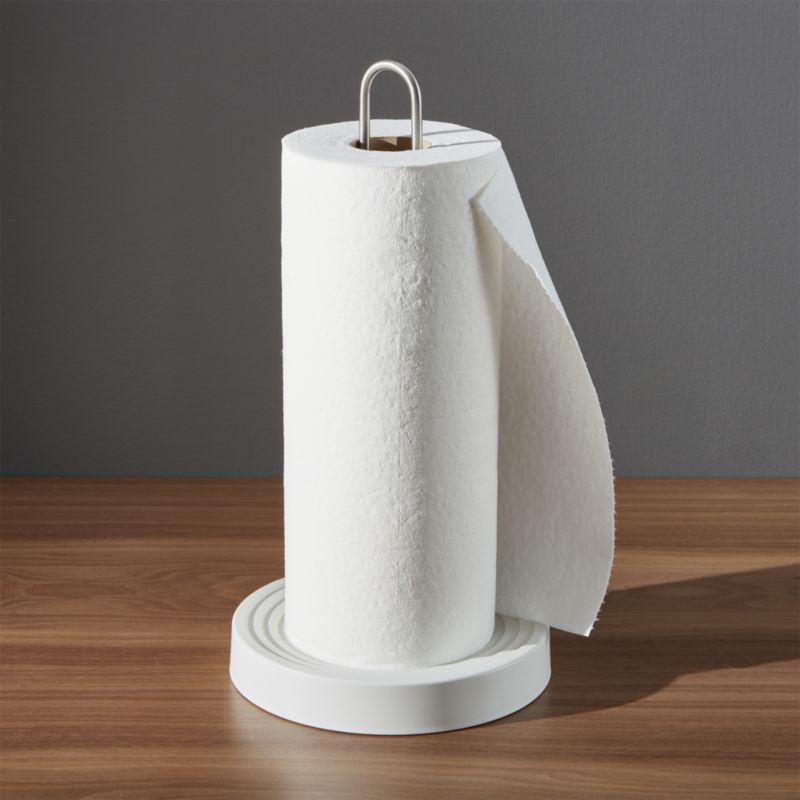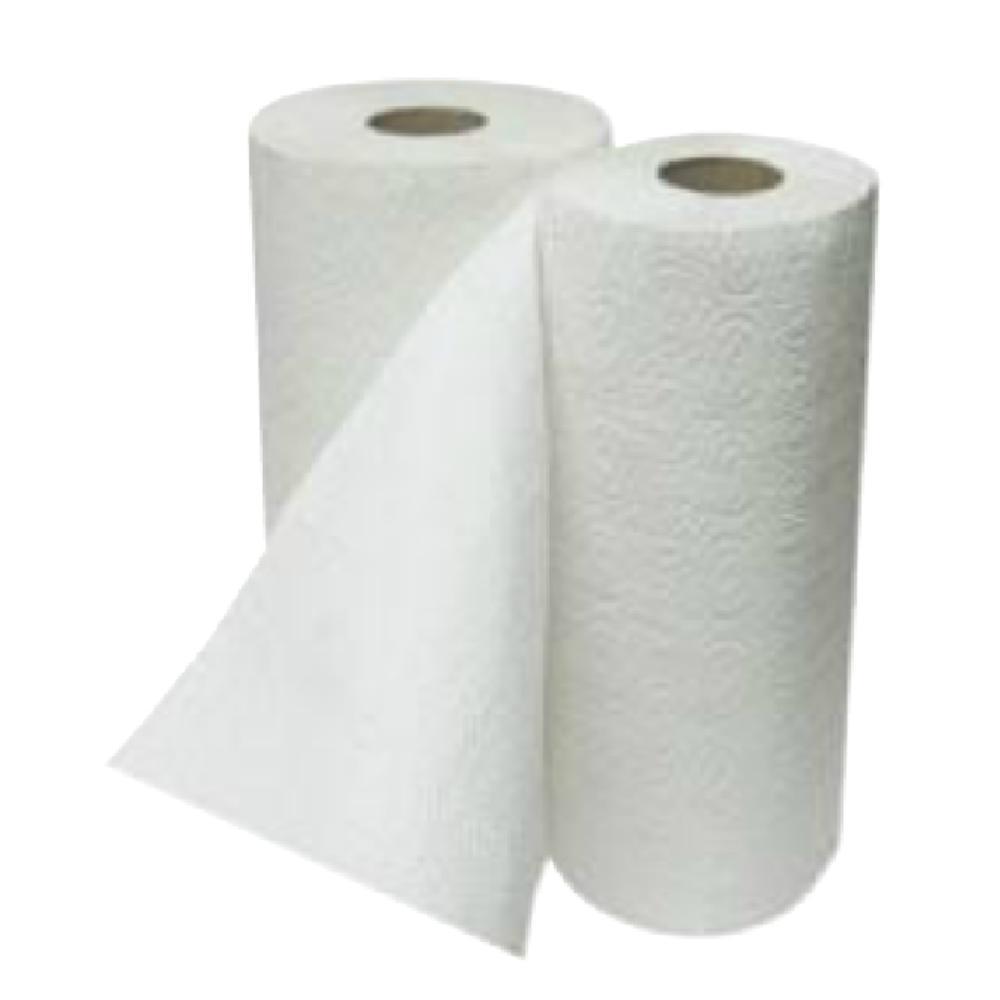The first image is the image on the left, the second image is the image on the right. Assess this claim about the two images: "there are at least two rolls of paper towels". Correct or not? Answer yes or no. Yes. 